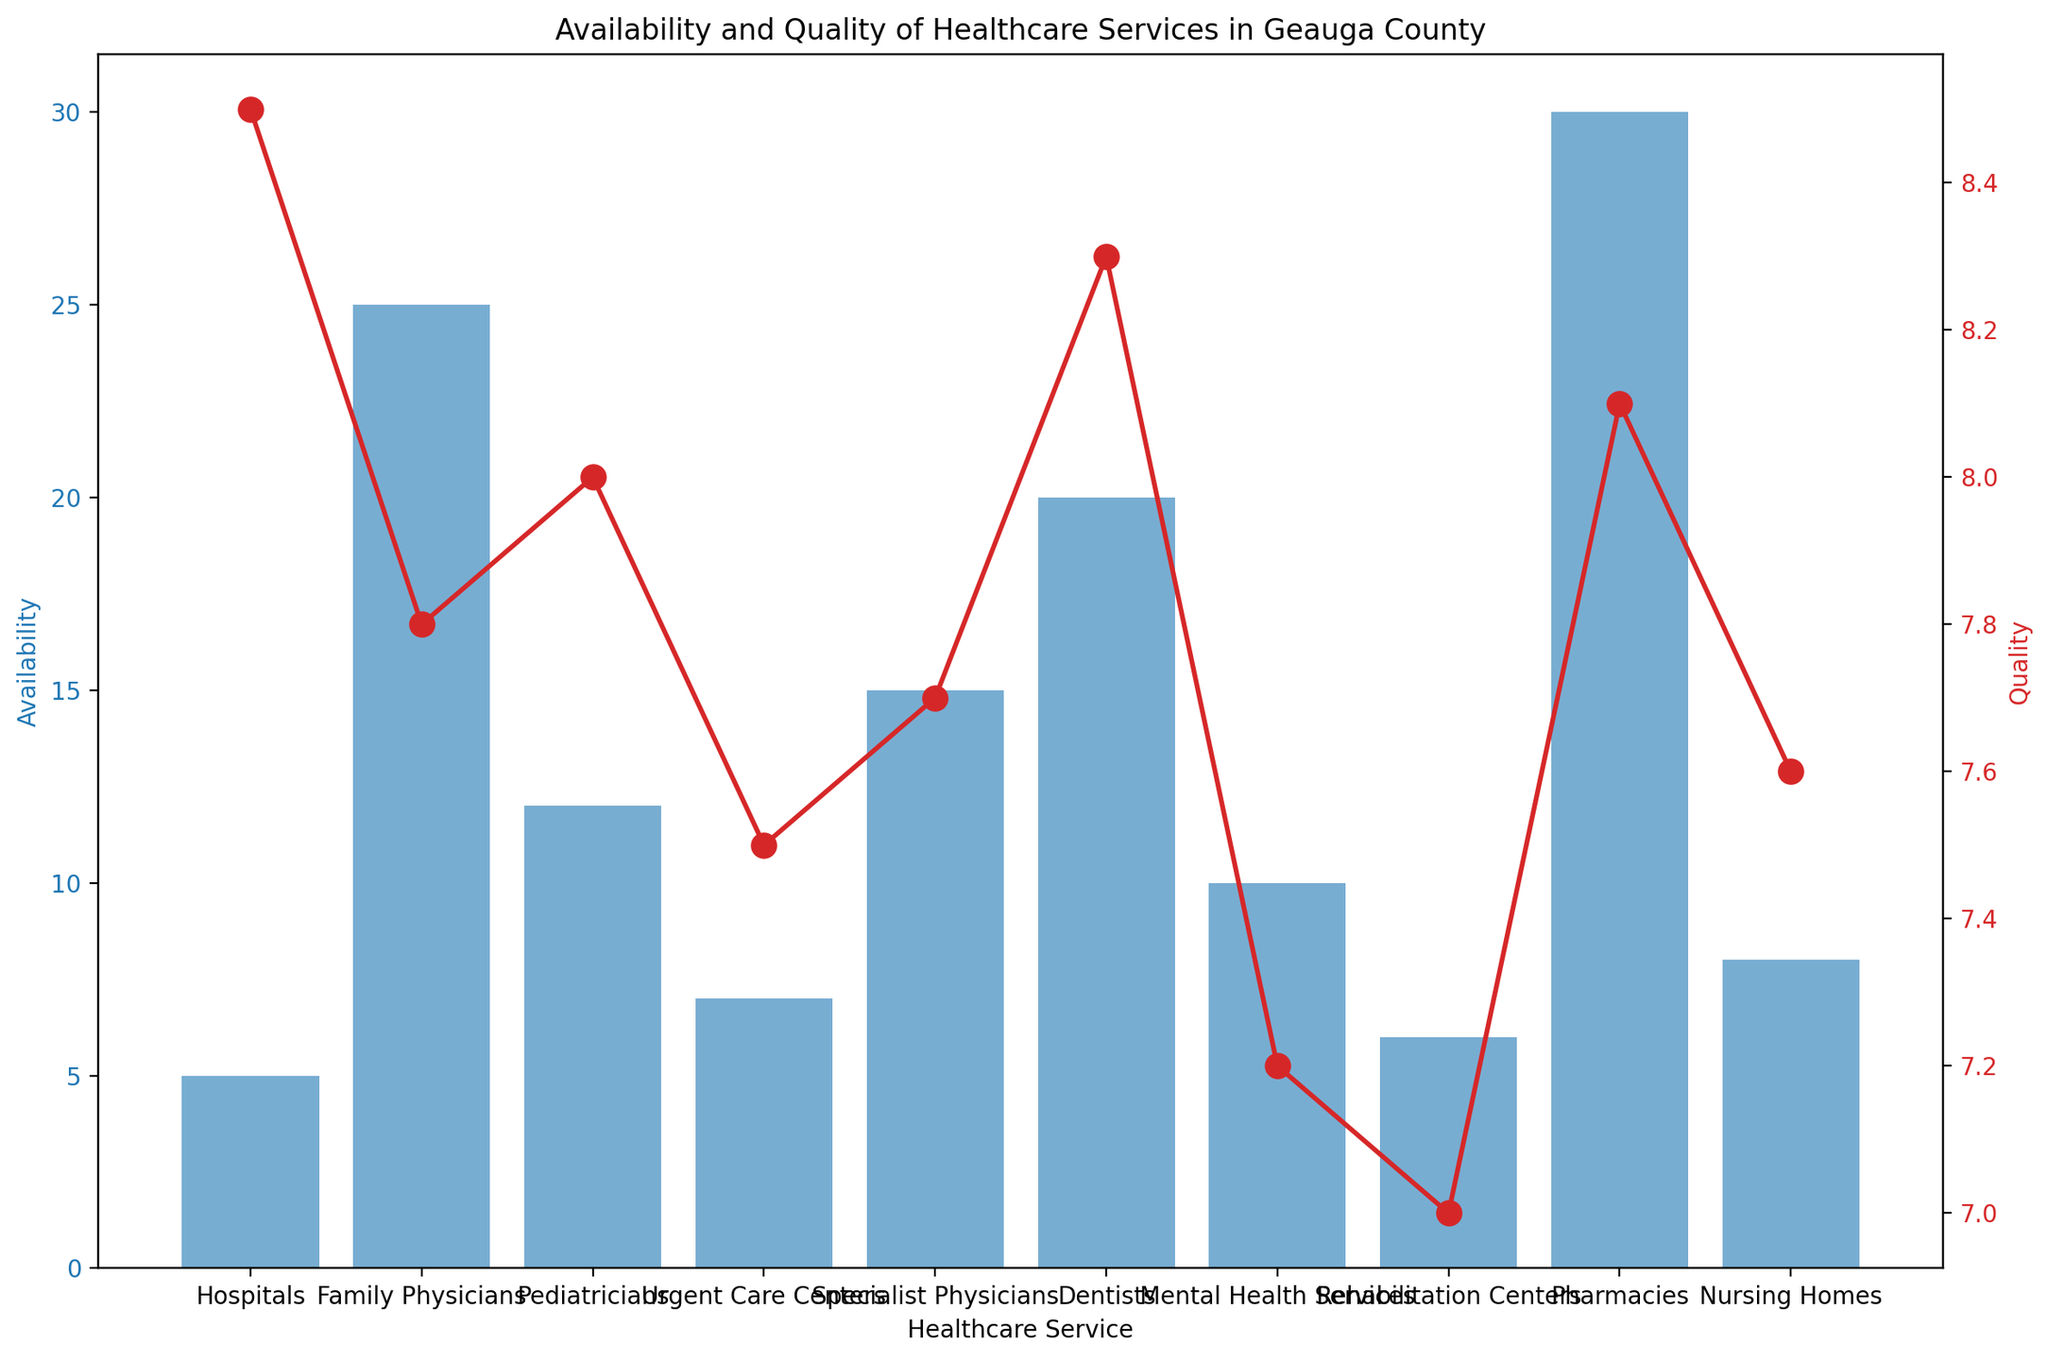what healthcare service has the highest availability? The bars represent availability, and the highest bar is the one for "Pharmacies" at 30.
Answer: Pharmacies Which healthcare service has the lowest quality rating? The red line represents the quality rating, and the lowest point on the graph is "Rehabilitation Centers" with a rating of 7.0.
Answer: Rehabilitation Centers How does the availability of family physicians compare to specialist physicians? The blue bar for "Family Physicians" reaches 25, while the blue bar for "Specialist Physicians" reaches 15.
Answer: Family Physicians has higher availability What is the average quality rating across all healthcare services? To find the average, sum all quality ratings (8.5 + 7.8 + 8.0 + 7.5 + 7.7 + 8.3 + 7.2 + 7.0 + 8.1 + 7.6) = 77.7, then divide by the number of healthcare services (10), which equals 7.77.
Answer: 7.77 Which service has a higher quality rating: Pediatricians or Mental Health Services? Looking at the red line, "Pediatricians" has a rating of 8.0 and "Mental Health Services" has a rating of 7.2.
Answer: Pediatricians What is the difference in availability between hospitals and urgent care centers? Hospitals have an availability of 5, and urgent care centers have an availability of 7. Subtract 5 from 7 to get the difference.
Answer: 2 Is the quality rating of nursing homes higher or lower than the average quality rating? The quality rating for nursing homes is 7.6. The average quality rating is 7.77. Since 7.6 is less than 7.77, it’s lower.
Answer: Lower How many healthcare services have an availability of 10 or more? Counting the bars with a height equal or greater than 10, we have Family Physicians (25), Pediatricians (12), Specialist Physicians (15), Dentists (20), Mental Health Services (10), Pharmacies (30).
Answer: 6 What is the combined availability of dentists and mental health services? Add the availability numbers: Dentists (20) + Mental Health Services (10) = 30.
Answer: 30 Which healthcare service has a higher quality rating, dentists or hospitals? Looking at the red line, "Dentists" has a quality rating of 8.3, while "Hospitals" have a rating of 8.5.
Answer: Hospitals 